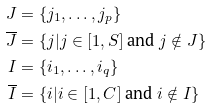<formula> <loc_0><loc_0><loc_500><loc_500>J & = \{ j _ { 1 } , \dots , j _ { p } \} \\ \overline { J } & = \{ j | j \in [ 1 , S ] \text { and } j \notin J \} \\ I & = \{ i _ { 1 } , \dots , i _ { q } \} \\ \overline { I } & = \{ i | i \in [ 1 , C ] \text { and } i \notin I \}</formula> 